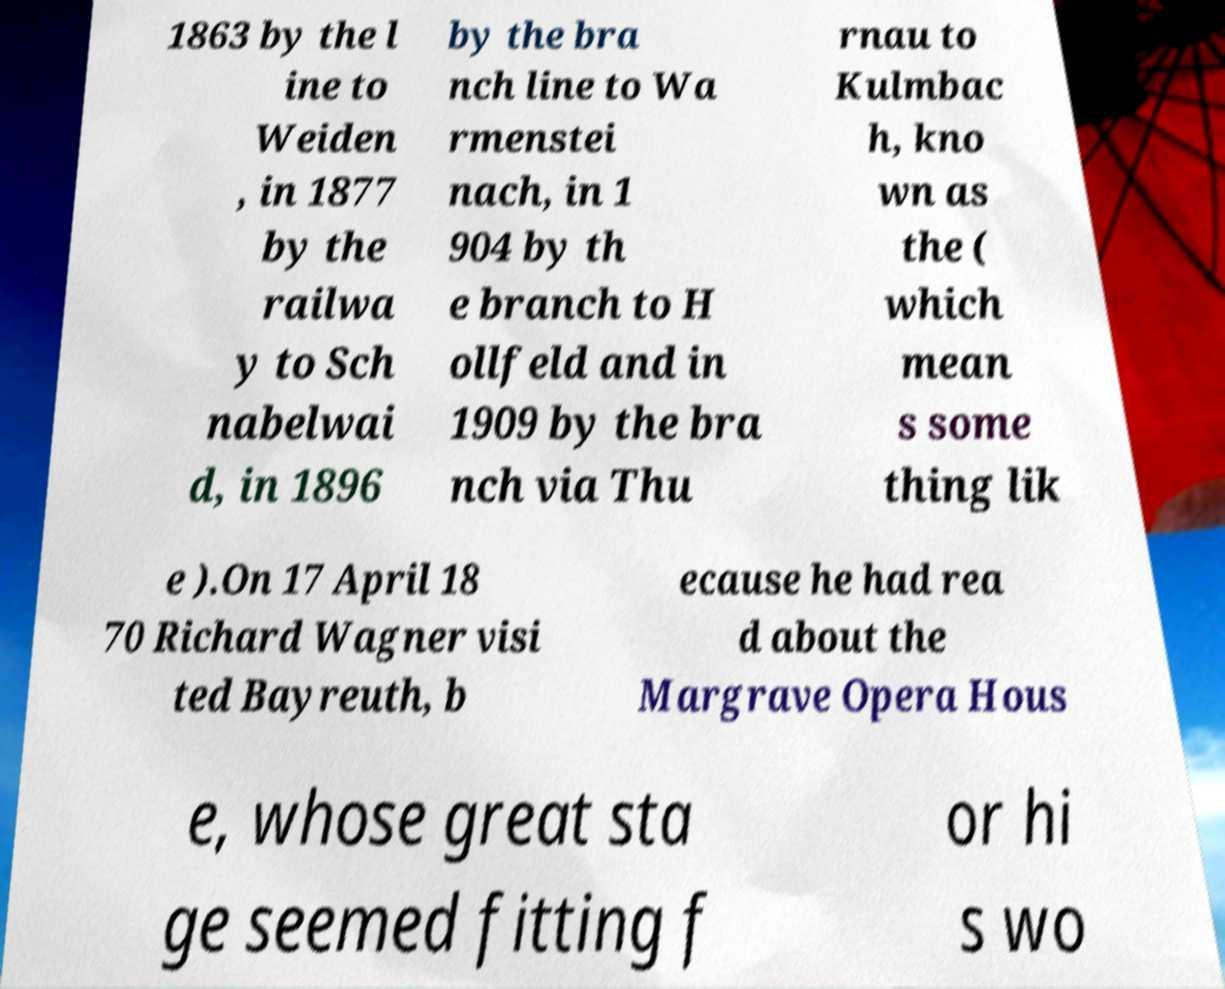Could you extract and type out the text from this image? 1863 by the l ine to Weiden , in 1877 by the railwa y to Sch nabelwai d, in 1896 by the bra nch line to Wa rmenstei nach, in 1 904 by th e branch to H ollfeld and in 1909 by the bra nch via Thu rnau to Kulmbac h, kno wn as the ( which mean s some thing lik e ).On 17 April 18 70 Richard Wagner visi ted Bayreuth, b ecause he had rea d about the Margrave Opera Hous e, whose great sta ge seemed fitting f or hi s wo 